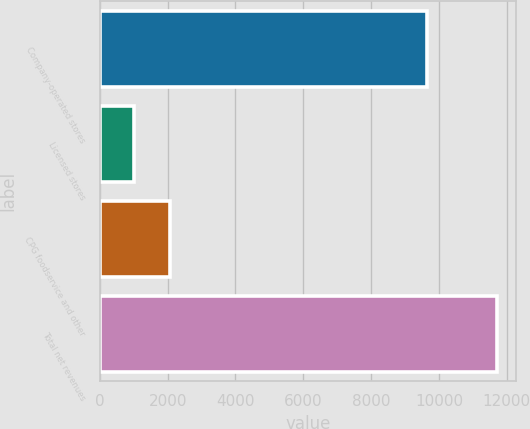<chart> <loc_0><loc_0><loc_500><loc_500><bar_chart><fcel>Company-operated stores<fcel>Licensed stores<fcel>CPG foodservice and other<fcel>Total net revenues<nl><fcel>9632.4<fcel>1007.5<fcel>2076.79<fcel>11700.4<nl></chart> 